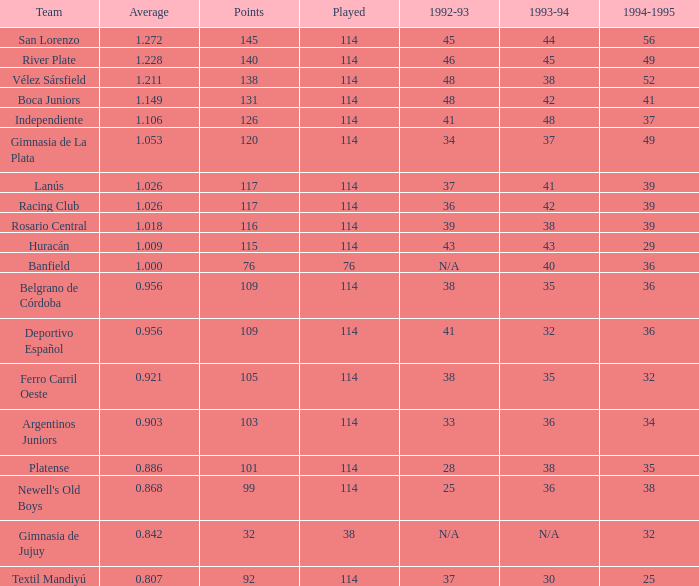Could you help me parse every detail presented in this table? {'header': ['Team', 'Average', 'Points', 'Played', '1992-93', '1993-94', '1994-1995'], 'rows': [['San Lorenzo', '1.272', '145', '114', '45', '44', '56'], ['River Plate', '1.228', '140', '114', '46', '45', '49'], ['Vélez Sársfield', '1.211', '138', '114', '48', '38', '52'], ['Boca Juniors', '1.149', '131', '114', '48', '42', '41'], ['Independiente', '1.106', '126', '114', '41', '48', '37'], ['Gimnasia de La Plata', '1.053', '120', '114', '34', '37', '49'], ['Lanús', '1.026', '117', '114', '37', '41', '39'], ['Racing Club', '1.026', '117', '114', '36', '42', '39'], ['Rosario Central', '1.018', '116', '114', '39', '38', '39'], ['Huracán', '1.009', '115', '114', '43', '43', '29'], ['Banfield', '1.000', '76', '76', 'N/A', '40', '36'], ['Belgrano de Córdoba', '0.956', '109', '114', '38', '35', '36'], ['Deportivo Español', '0.956', '109', '114', '41', '32', '36'], ['Ferro Carril Oeste', '0.921', '105', '114', '38', '35', '32'], ['Argentinos Juniors', '0.903', '103', '114', '33', '36', '34'], ['Platense', '0.886', '101', '114', '28', '38', '35'], ["Newell's Old Boys", '0.868', '99', '114', '25', '36', '38'], ['Gimnasia de Jujuy', '0.842', '32', '38', 'N/A', 'N/A', '32'], ['Textil Mandiyú', '0.807', '92', '114', '37', '30', '25']]} What was the team during 1993-94 for 32? Deportivo Español. 